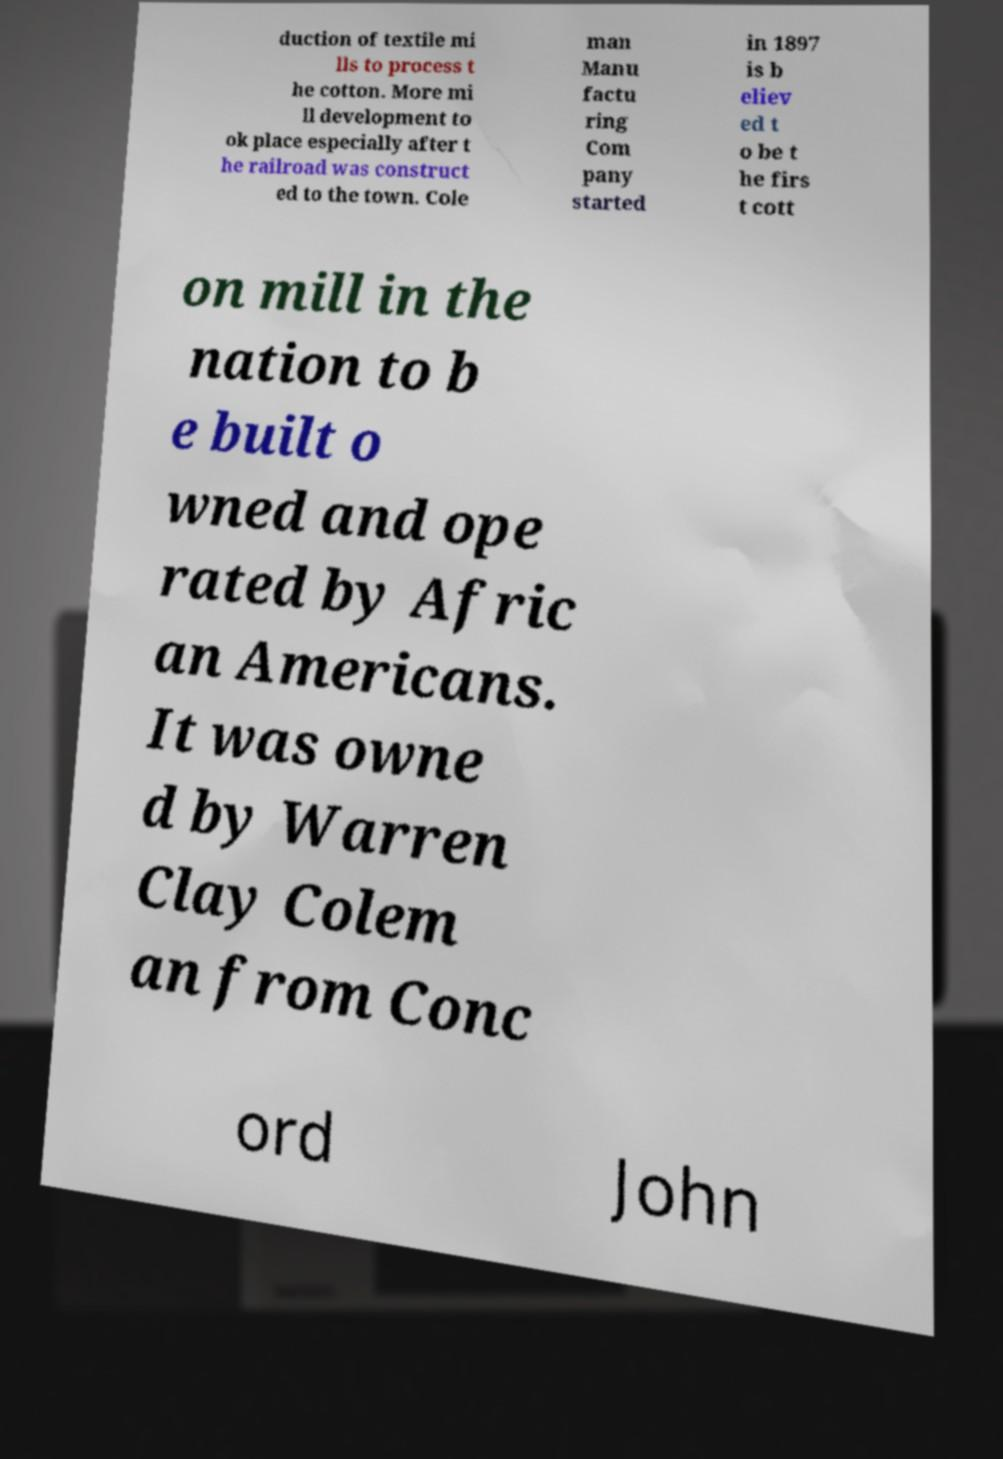For documentation purposes, I need the text within this image transcribed. Could you provide that? duction of textile mi lls to process t he cotton. More mi ll development to ok place especially after t he railroad was construct ed to the town. Cole man Manu factu ring Com pany started in 1897 is b eliev ed t o be t he firs t cott on mill in the nation to b e built o wned and ope rated by Afric an Americans. It was owne d by Warren Clay Colem an from Conc ord John 